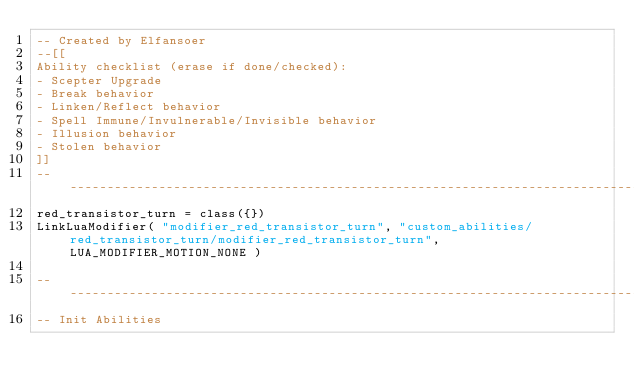<code> <loc_0><loc_0><loc_500><loc_500><_Lua_>-- Created by Elfansoer
--[[
Ability checklist (erase if done/checked):
- Scepter Upgrade
- Break behavior
- Linken/Reflect behavior
- Spell Immune/Invulnerable/Invisible behavior
- Illusion behavior
- Stolen behavior
]]
--------------------------------------------------------------------------------
red_transistor_turn = class({})
LinkLuaModifier( "modifier_red_transistor_turn", "custom_abilities/red_transistor_turn/modifier_red_transistor_turn", LUA_MODIFIER_MOTION_NONE )

--------------------------------------------------------------------------------
-- Init Abilities</code> 